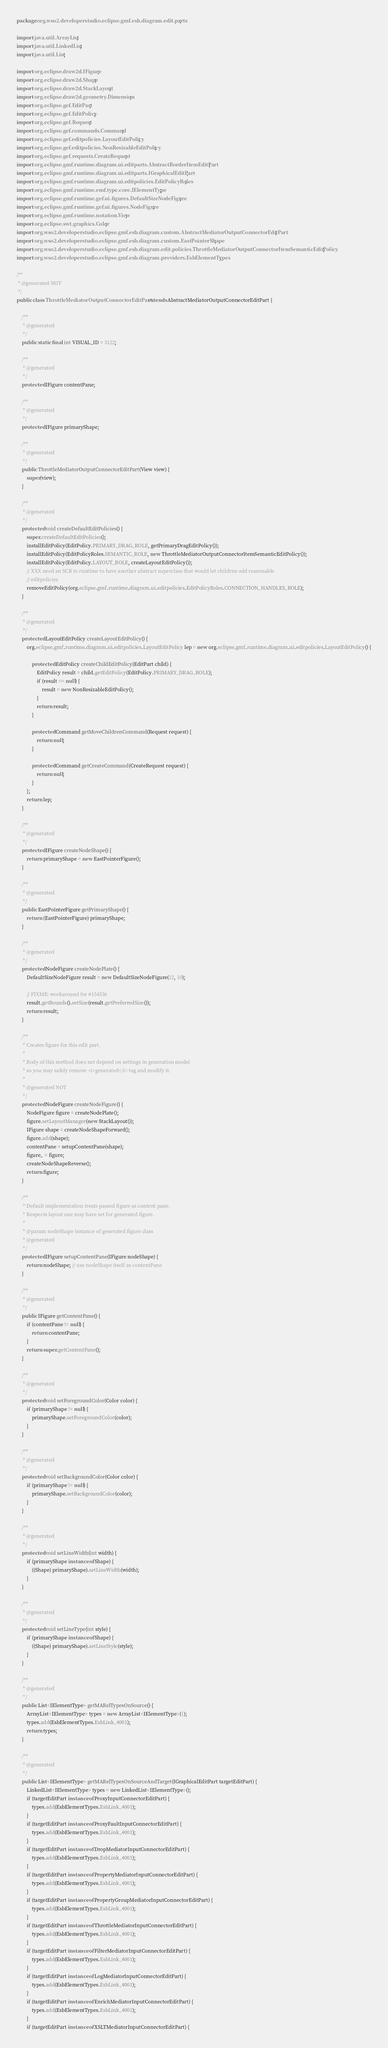Convert code to text. <code><loc_0><loc_0><loc_500><loc_500><_Java_>package org.wso2.developerstudio.eclipse.gmf.esb.diagram.edit.parts;

import java.util.ArrayList;
import java.util.LinkedList;
import java.util.List;

import org.eclipse.draw2d.IFigure;
import org.eclipse.draw2d.Shape;
import org.eclipse.draw2d.StackLayout;
import org.eclipse.draw2d.geometry.Dimension;
import org.eclipse.gef.EditPart;
import org.eclipse.gef.EditPolicy;
import org.eclipse.gef.Request;
import org.eclipse.gef.commands.Command;
import org.eclipse.gef.editpolicies.LayoutEditPolicy;
import org.eclipse.gef.editpolicies.NonResizableEditPolicy;
import org.eclipse.gef.requests.CreateRequest;
import org.eclipse.gmf.runtime.diagram.ui.editparts.AbstractBorderItemEditPart;
import org.eclipse.gmf.runtime.diagram.ui.editparts.IGraphicalEditPart;
import org.eclipse.gmf.runtime.diagram.ui.editpolicies.EditPolicyRoles;
import org.eclipse.gmf.runtime.emf.type.core.IElementType;
import org.eclipse.gmf.runtime.gef.ui.figures.DefaultSizeNodeFigure;
import org.eclipse.gmf.runtime.gef.ui.figures.NodeFigure;
import org.eclipse.gmf.runtime.notation.View;
import org.eclipse.swt.graphics.Color;
import org.wso2.developerstudio.eclipse.gmf.esb.diagram.custom.AbstractMediatorOutputConnectorEditPart;
import org.wso2.developerstudio.eclipse.gmf.esb.diagram.custom.EastPointerShape;
import org.wso2.developerstudio.eclipse.gmf.esb.diagram.edit.policies.ThrottleMediatorOutputConnectorItemSemanticEditPolicy;
import org.wso2.developerstudio.eclipse.gmf.esb.diagram.providers.EsbElementTypes;

/**
 * @generated NOT
 */
public class ThrottleMediatorOutputConnectorEditPart extends AbstractMediatorOutputConnectorEditPart {

    /**
     * @generated
     */
    public static final int VISUAL_ID = 3122;

    /**
     * @generated
     */
    protected IFigure contentPane;

    /**
     * @generated
     */
    protected IFigure primaryShape;

    /**
     * @generated
     */
    public ThrottleMediatorOutputConnectorEditPart(View view) {
        super(view);
    }

    /**
     * @generated
     */
    protected void createDefaultEditPolicies() {
        super.createDefaultEditPolicies();
        installEditPolicy(EditPolicy.PRIMARY_DRAG_ROLE, getPrimaryDragEditPolicy());
        installEditPolicy(EditPolicyRoles.SEMANTIC_ROLE, new ThrottleMediatorOutputConnectorItemSemanticEditPolicy());
        installEditPolicy(EditPolicy.LAYOUT_ROLE, createLayoutEditPolicy());
        // XXX need an SCR to runtime to have another abstract superclass that would let children add reasonable
        // editpolicies
        removeEditPolicy(org.eclipse.gmf.runtime.diagram.ui.editpolicies.EditPolicyRoles.CONNECTION_HANDLES_ROLE);
    }

    /**
     * @generated
     */
    protected LayoutEditPolicy createLayoutEditPolicy() {
        org.eclipse.gmf.runtime.diagram.ui.editpolicies.LayoutEditPolicy lep = new org.eclipse.gmf.runtime.diagram.ui.editpolicies.LayoutEditPolicy() {

            protected EditPolicy createChildEditPolicy(EditPart child) {
                EditPolicy result = child.getEditPolicy(EditPolicy.PRIMARY_DRAG_ROLE);
                if (result == null) {
                    result = new NonResizableEditPolicy();
                }
                return result;
            }

            protected Command getMoveChildrenCommand(Request request) {
                return null;
            }

            protected Command getCreateCommand(CreateRequest request) {
                return null;
            }
        };
        return lep;
    }

    /**
     * @generated
     */
    protected IFigure createNodeShape() {
        return primaryShape = new EastPointerFigure();
    }

    /**
     * @generated
     */
    public EastPointerFigure getPrimaryShape() {
        return (EastPointerFigure) primaryShape;
    }

    /**
     * @generated
     */
    protected NodeFigure createNodePlate() {
        DefaultSizeNodeFigure result = new DefaultSizeNodeFigure(12, 10);

        // FIXME: workaround for #154536
        result.getBounds().setSize(result.getPreferredSize());
        return result;
    }

    /**
     * Creates figure for this edit part.
     * 
     * Body of this method does not depend on settings in generation model
     * so you may safely remove <i>generated</i> tag and modify it.
     * 
     * @generated NOT
     */
    protected NodeFigure createNodeFigure() {
        NodeFigure figure = createNodePlate();
        figure.setLayoutManager(new StackLayout());
        IFigure shape = createNodeShapeForward();
        figure.add(shape);
        contentPane = setupContentPane(shape);
        figure_ = figure;
        createNodeShapeReverse();
        return figure;
    }

    /**
     * Default implementation treats passed figure as content pane.
     * Respects layout one may have set for generated figure.
     * 
     * @param nodeShape instance of generated figure class
     * @generated
     */
    protected IFigure setupContentPane(IFigure nodeShape) {
        return nodeShape; // use nodeShape itself as contentPane
    }

    /**
     * @generated
     */
    public IFigure getContentPane() {
        if (contentPane != null) {
            return contentPane;
        }
        return super.getContentPane();
    }

    /**
     * @generated
     */
    protected void setForegroundColor(Color color) {
        if (primaryShape != null) {
            primaryShape.setForegroundColor(color);
        }
    }

    /**
     * @generated
     */
    protected void setBackgroundColor(Color color) {
        if (primaryShape != null) {
            primaryShape.setBackgroundColor(color);
        }
    }

    /**
     * @generated
     */
    protected void setLineWidth(int width) {
        if (primaryShape instanceof Shape) {
            ((Shape) primaryShape).setLineWidth(width);
        }
    }

    /**
     * @generated
     */
    protected void setLineType(int style) {
        if (primaryShape instanceof Shape) {
            ((Shape) primaryShape).setLineStyle(style);
        }
    }

    /**
     * @generated
     */
    public List<IElementType> getMARelTypesOnSource() {
        ArrayList<IElementType> types = new ArrayList<IElementType>(1);
        types.add(EsbElementTypes.EsbLink_4001);
        return types;
    }

    /**
     * @generated
     */
    public List<IElementType> getMARelTypesOnSourceAndTarget(IGraphicalEditPart targetEditPart) {
        LinkedList<IElementType> types = new LinkedList<IElementType>();
        if (targetEditPart instanceof ProxyInputConnectorEditPart) {
            types.add(EsbElementTypes.EsbLink_4001);
        }
        if (targetEditPart instanceof ProxyFaultInputConnectorEditPart) {
            types.add(EsbElementTypes.EsbLink_4001);
        }
        if (targetEditPart instanceof DropMediatorInputConnectorEditPart) {
            types.add(EsbElementTypes.EsbLink_4001);
        }
        if (targetEditPart instanceof PropertyMediatorInputConnectorEditPart) {
            types.add(EsbElementTypes.EsbLink_4001);
        }
        if (targetEditPart instanceof PropertyGroupMediatorInputConnectorEditPart) {
            types.add(EsbElementTypes.EsbLink_4001);
        }
        if (targetEditPart instanceof ThrottleMediatorInputConnectorEditPart) {
            types.add(EsbElementTypes.EsbLink_4001);
        }
        if (targetEditPart instanceof FilterMediatorInputConnectorEditPart) {
            types.add(EsbElementTypes.EsbLink_4001);
        }
        if (targetEditPart instanceof LogMediatorInputConnectorEditPart) {
            types.add(EsbElementTypes.EsbLink_4001);
        }
        if (targetEditPart instanceof EnrichMediatorInputConnectorEditPart) {
            types.add(EsbElementTypes.EsbLink_4001);
        }
        if (targetEditPart instanceof XSLTMediatorInputConnectorEditPart) {</code> 